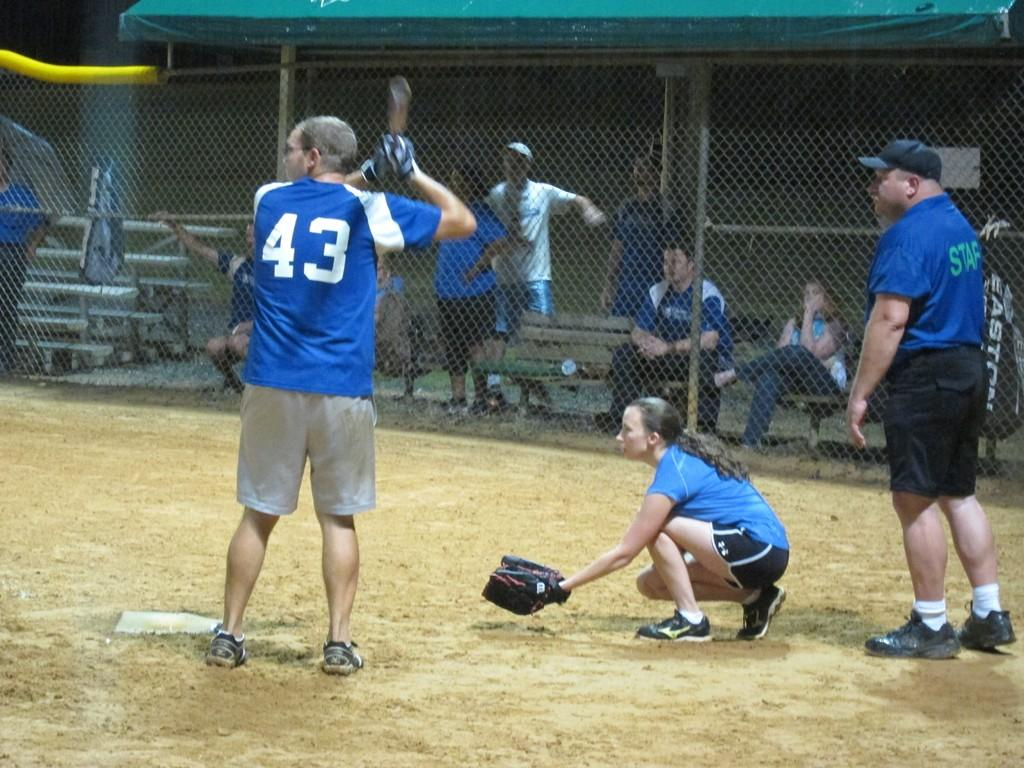<image>
Render a clear and concise summary of the photo. Baseball player 43 in a blue jersey is at bat. 